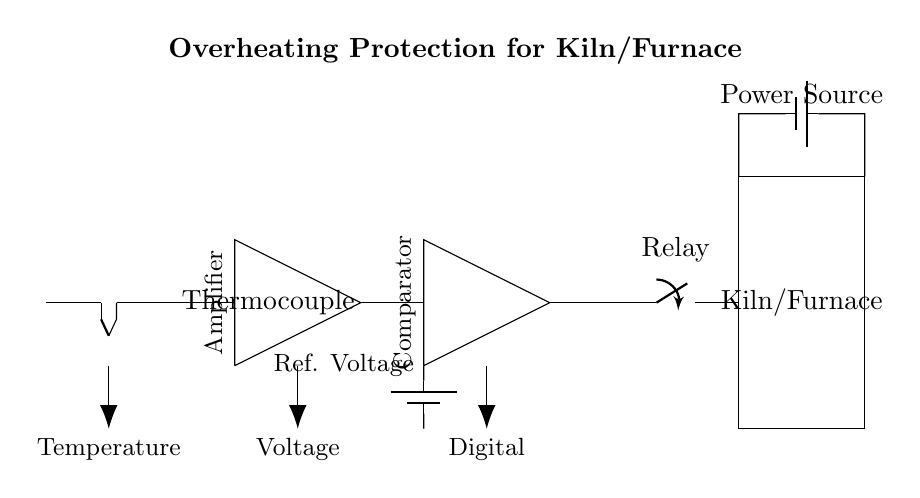What is the first component in the circuit? The first component in the circuit is the thermocouple, which is used to measure temperature.
Answer: Thermocouple What type of amplifier is represented in the circuit? The circuit includes a standard amplifier which is part of the temperature sensing and regulation system.
Answer: Amplifier What is the purpose of the comparator in this circuit? The comparator is used to compare the amplified temperature signal with a reference voltage to determine if the temperature exceeds a certain limit.
Answer: Compare temperature What is the source of power for the kiln or furnace? The power source is a battery that supplies the necessary voltage to operate the kiln or furnace.
Answer: Battery How many components are involved in the overheating protection circuit? There are five main components in the circuit: thermocouple, amplifier, comparator, relay, and power source.
Answer: Five What happens if the temperature exceeds the reference voltage? If the temperature exceeds the reference voltage, the relay activates, disconnecting power to the kiln or furnace to prevent overheating.
Answer: Relay activates What is the role of the relay in this circuit? The relay acts as a switch that controls the power supply to the kiln or furnace based on the comparator's output, ensuring safe operation.
Answer: Disconnect power 